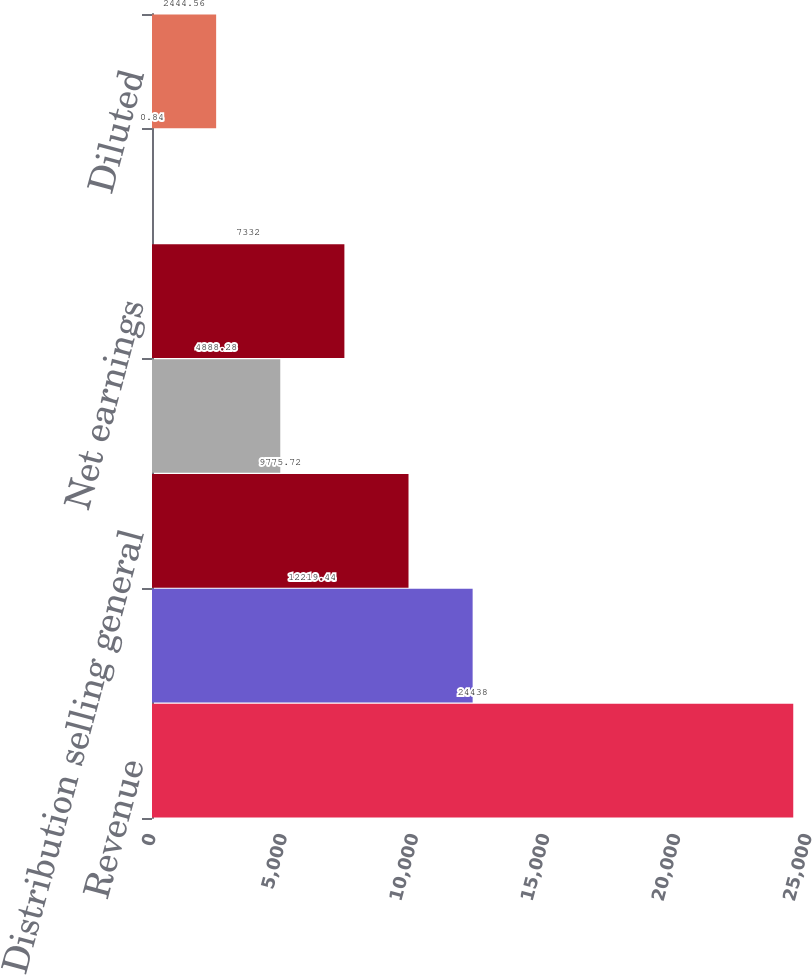<chart> <loc_0><loc_0><loc_500><loc_500><bar_chart><fcel>Revenue<fcel>Gross margin<fcel>Distribution selling general<fcel>Earnings from continuing<fcel>Net earnings<fcel>Basic<fcel>Diluted<nl><fcel>24438<fcel>12219.4<fcel>9775.72<fcel>4888.28<fcel>7332<fcel>0.84<fcel>2444.56<nl></chart> 